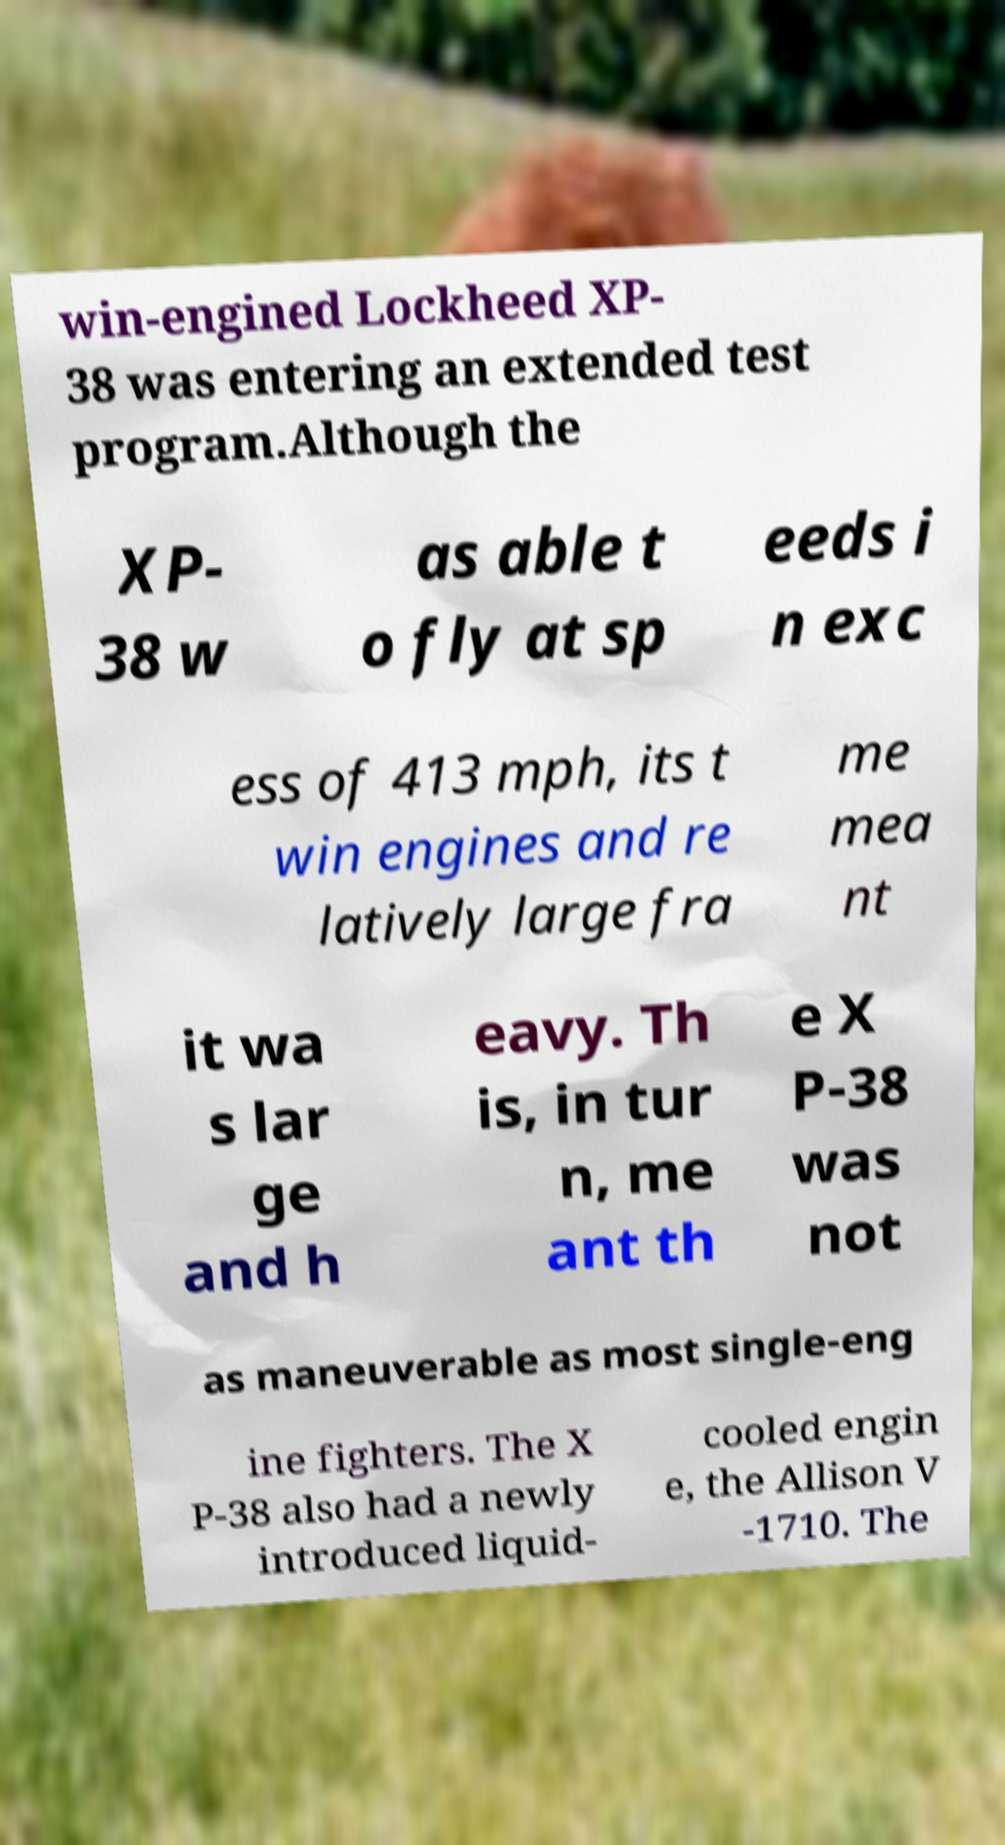What messages or text are displayed in this image? I need them in a readable, typed format. win-engined Lockheed XP- 38 was entering an extended test program.Although the XP- 38 w as able t o fly at sp eeds i n exc ess of 413 mph, its t win engines and re latively large fra me mea nt it wa s lar ge and h eavy. Th is, in tur n, me ant th e X P-38 was not as maneuverable as most single-eng ine fighters. The X P-38 also had a newly introduced liquid- cooled engin e, the Allison V -1710. The 